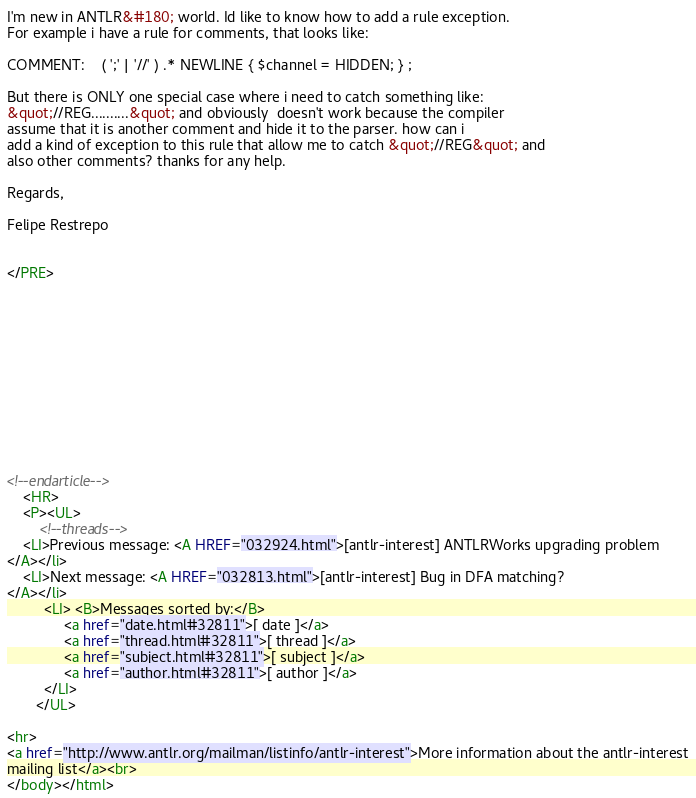<code> <loc_0><loc_0><loc_500><loc_500><_HTML_>
I'm new in ANTLR&#180; world. Id like to know how to add a rule exception. 
For example i have a rule for comments, that looks like:

COMMENT:    ( ';' | '//' ) .* NEWLINE { $channel = HIDDEN; } ;

But there is ONLY one special case where i need to catch something like: 
&quot;//REG..........&quot; and obviously  doesn't work because the compiler 
assume that it is another comment and hide it to the parser. how can i 
add a kind of exception to this rule that allow me to catch &quot;//REG&quot; and 
also other comments? thanks for any help.

Regards,

Felipe Restrepo


</PRE>












<!--endarticle-->
    <HR>
    <P><UL>
        <!--threads-->
	<LI>Previous message: <A HREF="032924.html">[antlr-interest] ANTLRWorks upgrading problem
</A></li>
	<LI>Next message: <A HREF="032813.html">[antlr-interest] Bug in DFA matching?
</A></li>
         <LI> <B>Messages sorted by:</B> 
              <a href="date.html#32811">[ date ]</a>
              <a href="thread.html#32811">[ thread ]</a>
              <a href="subject.html#32811">[ subject ]</a>
              <a href="author.html#32811">[ author ]</a>
         </LI>
       </UL>

<hr>
<a href="http://www.antlr.org/mailman/listinfo/antlr-interest">More information about the antlr-interest
mailing list</a><br>
</body></html>
</code> 